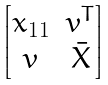Convert formula to latex. <formula><loc_0><loc_0><loc_500><loc_500>\begin{bmatrix} x _ { 1 1 } & v ^ { T } \\ v & \bar { X } \end{bmatrix}</formula> 